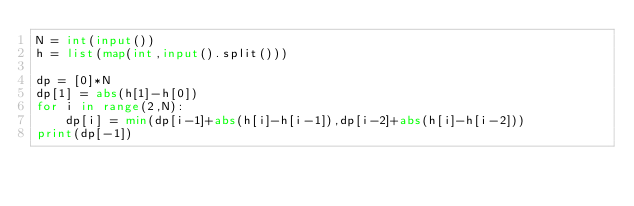Convert code to text. <code><loc_0><loc_0><loc_500><loc_500><_Python_>N = int(input())
h = list(map(int,input().split()))

dp = [0]*N
dp[1] = abs(h[1]-h[0])
for i in range(2,N):
    dp[i] = min(dp[i-1]+abs(h[i]-h[i-1]),dp[i-2]+abs(h[i]-h[i-2]))
print(dp[-1])</code> 